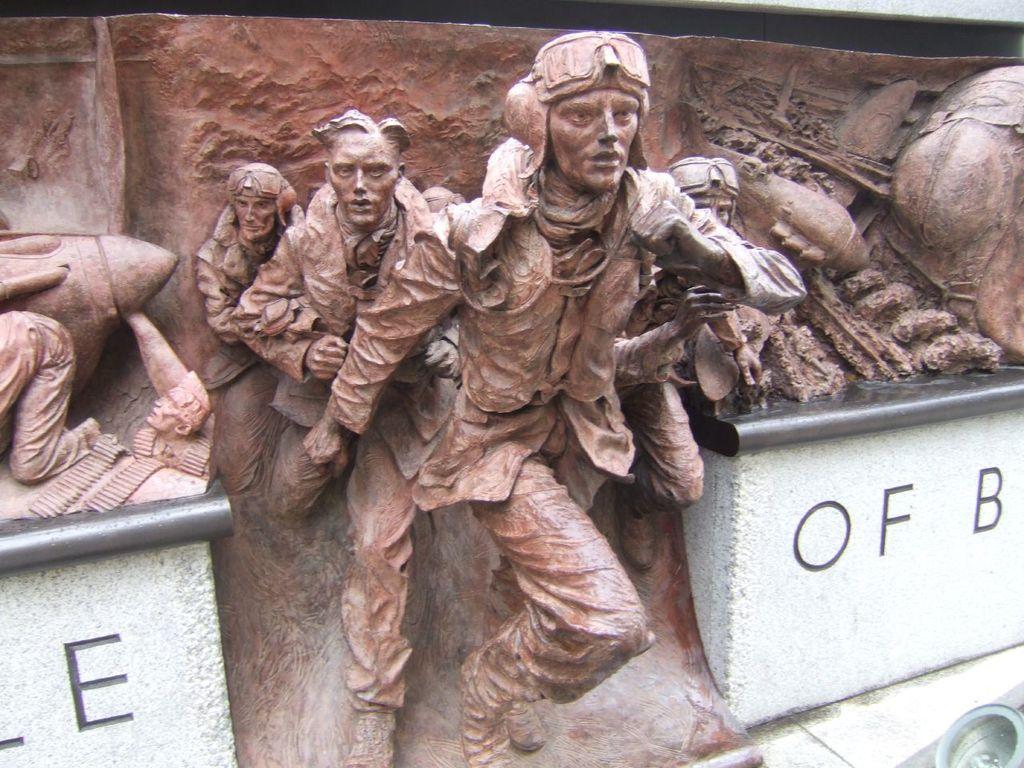How would you summarize this image in a sentence or two? In this picture there are statues of few persons and there is a wall which has something written on either sides of it and there are some other objects in the right corner. 